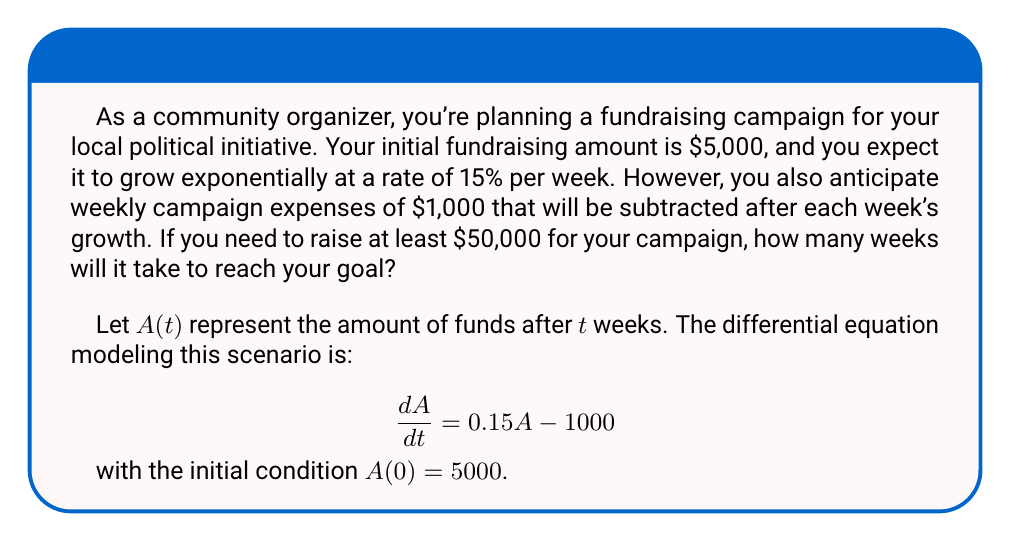Help me with this question. To solve this problem, we need to solve the given differential equation and then determine when the solution reaches $50,000.

1) The general solution to the differential equation $\frac{dA}{dt} = 0.15A - 1000$ is:

   $$A(t) = Ce^{0.15t} + \frac{1000}{0.15} = Ce^{0.15t} + \frac{20000}{3}$$

2) Using the initial condition $A(0) = 5000$, we can find $C$:

   $$5000 = C + \frac{20000}{3}$$
   $$C = 5000 - \frac{20000}{3} = -\frac{5000}{3}$$

3) Therefore, the particular solution is:

   $$A(t) = -\frac{5000}{3}e^{0.15t} + \frac{20000}{3}$$

4) To find when this reaches $50,000, we solve:

   $$50000 = -\frac{5000}{3}e^{0.15t} + \frac{20000}{3}$$

5) Rearranging:

   $$\frac{130000}{3} = \frac{5000}{3}e^{0.15t}$$
   $$26 = e^{0.15t}$$

6) Taking the natural log of both sides:

   $$\ln(26) = 0.15t$$
   $$t = \frac{\ln(26)}{0.15} \approx 21.71$$

7) Since we can only have whole weeks, we need to round up to 22 weeks.
Answer: 22 weeks 